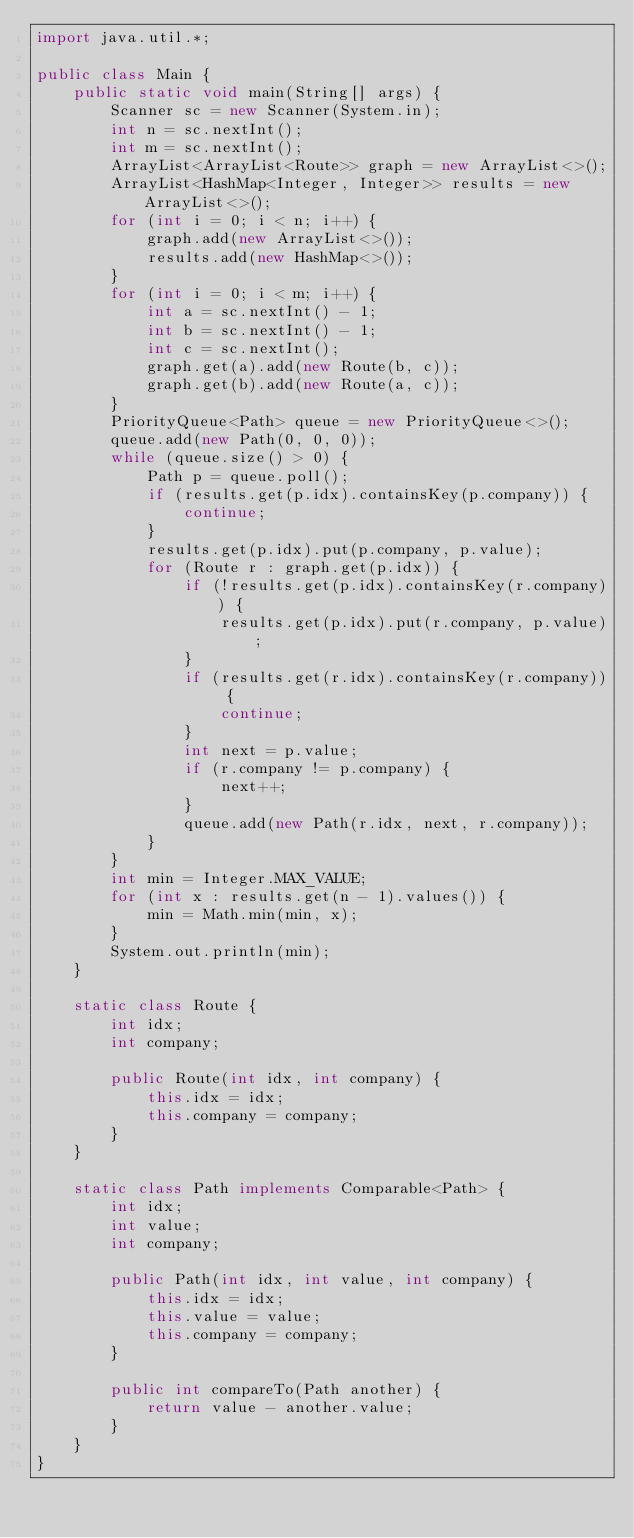<code> <loc_0><loc_0><loc_500><loc_500><_Java_>import java.util.*;

public class Main {
    public static void main(String[] args) {
        Scanner sc = new Scanner(System.in);
        int n = sc.nextInt();
        int m = sc.nextInt();
        ArrayList<ArrayList<Route>> graph = new ArrayList<>();
        ArrayList<HashMap<Integer, Integer>> results = new ArrayList<>();
        for (int i = 0; i < n; i++) {
            graph.add(new ArrayList<>());
            results.add(new HashMap<>());
        }
        for (int i = 0; i < m; i++) {
            int a = sc.nextInt() - 1;
            int b = sc.nextInt() - 1;
            int c = sc.nextInt();
            graph.get(a).add(new Route(b, c));
            graph.get(b).add(new Route(a, c));
        }
        PriorityQueue<Path> queue = new PriorityQueue<>();
        queue.add(new Path(0, 0, 0));
        while (queue.size() > 0) {
            Path p = queue.poll();
            if (results.get(p.idx).containsKey(p.company)) {
                continue;
            }
            results.get(p.idx).put(p.company, p.value);
            for (Route r : graph.get(p.idx)) {
                if (!results.get(p.idx).containsKey(r.company)) {
                    results.get(p.idx).put(r.company, p.value);
                }
                if (results.get(r.idx).containsKey(r.company)) {
                    continue;
                }
                int next = p.value;
                if (r.company != p.company) {
                    next++;
                }
                queue.add(new Path(r.idx, next, r.company));
            }
        }
        int min = Integer.MAX_VALUE;
        for (int x : results.get(n - 1).values()) {
            min = Math.min(min, x);
        }
        System.out.println(min);
    }
    
    static class Route {
        int idx;
        int company;
        
        public Route(int idx, int company) {
            this.idx = idx;
            this.company = company;
        }
    }
    
    static class Path implements Comparable<Path> {
        int idx;
        int value;
        int company;
        
        public Path(int idx, int value, int company) {
            this.idx = idx;
            this.value = value;
            this.company = company;
        }
        
        public int compareTo(Path another) {
            return value - another.value;
        }
    }
}</code> 